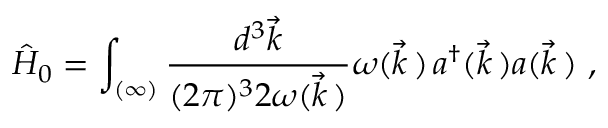Convert formula to latex. <formula><loc_0><loc_0><loc_500><loc_500>\hat { H } _ { 0 } = \int _ { ( \infty ) } \frac { d ^ { 3 } \vec { k } } { ( 2 \pi ) ^ { 3 } 2 \omega ( \vec { k } \, ) } \omega ( \vec { k } \, ) \, a ^ { \dagger } ( \vec { k } \, ) a ( \vec { k } \, ) \ ,</formula> 